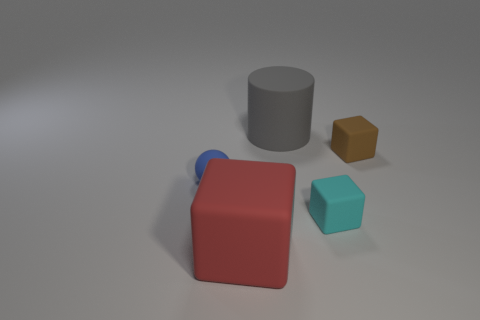Is there any other thing that has the same material as the tiny cyan block?
Offer a very short reply. Yes. What size is the object that is to the left of the large rubber object that is in front of the small thing that is left of the large red block?
Provide a succinct answer. Small. There is a blue sphere in front of the small brown thing; what is its size?
Give a very brief answer. Small. How many objects are either cyan rubber cubes or things in front of the gray rubber cylinder?
Give a very brief answer. 4. How many other things are there of the same size as the cyan matte cube?
Your response must be concise. 2. There is a large red object that is the same shape as the small brown matte object; what is its material?
Give a very brief answer. Rubber. Is the number of large red matte objects that are left of the cylinder greater than the number of big blue blocks?
Your answer should be very brief. Yes. Is there any other thing of the same color as the large cylinder?
Provide a succinct answer. No. There is a brown thing that is made of the same material as the red cube; what shape is it?
Provide a short and direct response. Cube. Is the material of the large object in front of the large rubber cylinder the same as the blue object?
Ensure brevity in your answer.  Yes. 